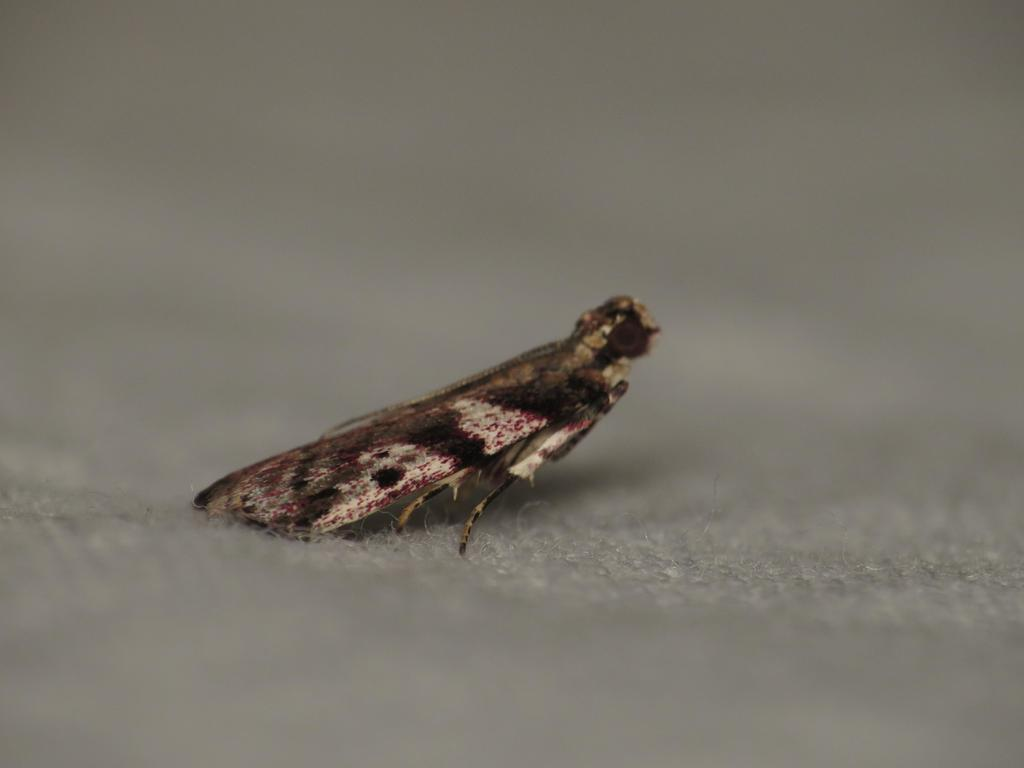What is located in the center of the image? There is an insect in the center of the image. What type of surface is visible at the bottom of the image? There is a floor visible at the bottom of the image. What type of hall can be seen in the background of the image? There is no hall visible in the image; it only features an insect and a floor. What type of dime is the insect holding in the image? There is no dime present in the image, and the insect is not holding anything. 